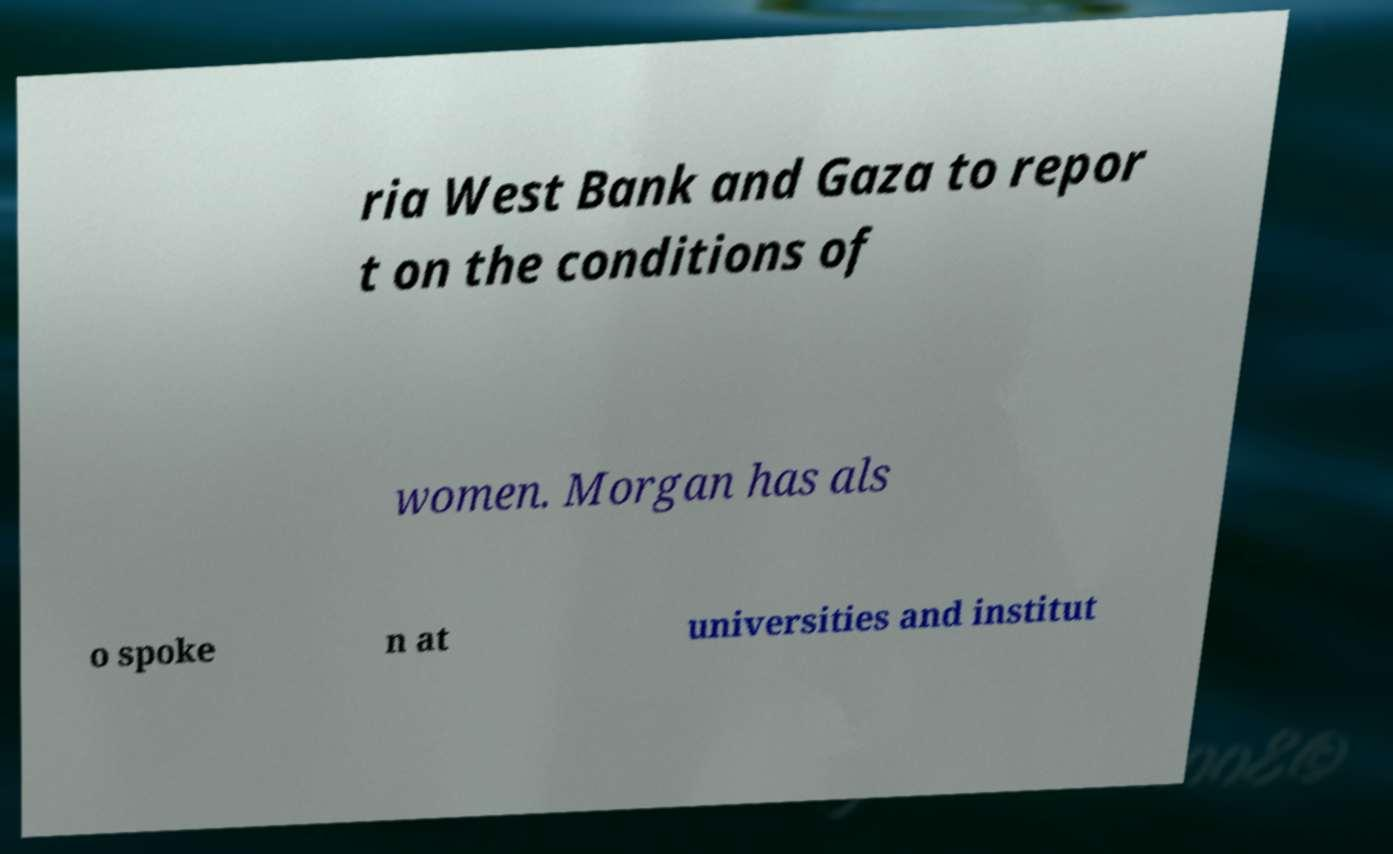Could you extract and type out the text from this image? ria West Bank and Gaza to repor t on the conditions of women. Morgan has als o spoke n at universities and institut 